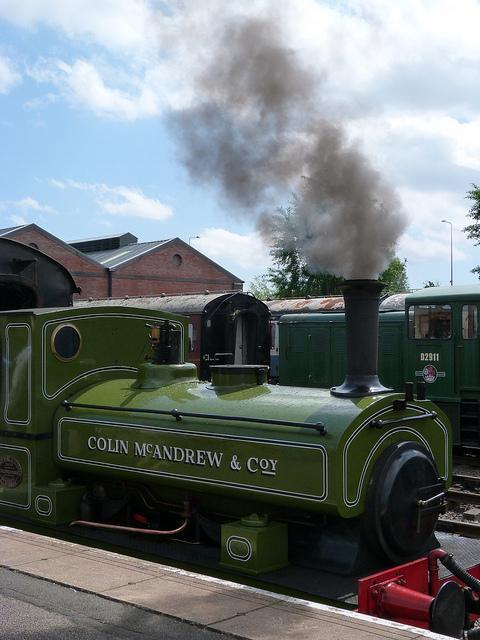How many trains are in the picture?
Give a very brief answer. 2. 